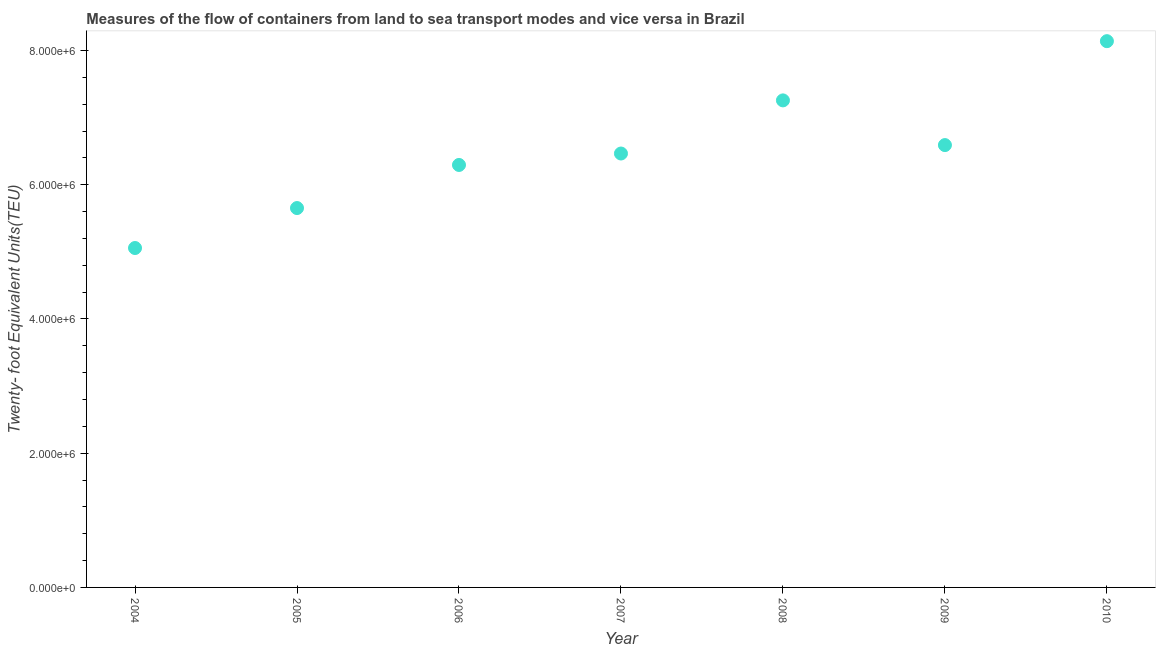What is the container port traffic in 2009?
Your response must be concise. 6.59e+06. Across all years, what is the maximum container port traffic?
Provide a short and direct response. 8.14e+06. Across all years, what is the minimum container port traffic?
Keep it short and to the point. 5.06e+06. What is the sum of the container port traffic?
Make the answer very short. 4.55e+07. What is the difference between the container port traffic in 2005 and 2006?
Keep it short and to the point. -6.42e+05. What is the average container port traffic per year?
Your answer should be very brief. 6.49e+06. What is the median container port traffic?
Give a very brief answer. 6.46e+06. In how many years, is the container port traffic greater than 3600000 TEU?
Your response must be concise. 7. What is the ratio of the container port traffic in 2005 to that in 2009?
Offer a very short reply. 0.86. Is the difference between the container port traffic in 2007 and 2009 greater than the difference between any two years?
Offer a terse response. No. What is the difference between the highest and the second highest container port traffic?
Make the answer very short. 8.82e+05. What is the difference between the highest and the lowest container port traffic?
Your response must be concise. 3.08e+06. In how many years, is the container port traffic greater than the average container port traffic taken over all years?
Your answer should be very brief. 3. Does the container port traffic monotonically increase over the years?
Provide a succinct answer. No. How many dotlines are there?
Keep it short and to the point. 1. What is the difference between two consecutive major ticks on the Y-axis?
Offer a very short reply. 2.00e+06. What is the title of the graph?
Provide a succinct answer. Measures of the flow of containers from land to sea transport modes and vice versa in Brazil. What is the label or title of the Y-axis?
Offer a very short reply. Twenty- foot Equivalent Units(TEU). What is the Twenty- foot Equivalent Units(TEU) in 2004?
Provide a succinct answer. 5.06e+06. What is the Twenty- foot Equivalent Units(TEU) in 2005?
Keep it short and to the point. 5.65e+06. What is the Twenty- foot Equivalent Units(TEU) in 2006?
Ensure brevity in your answer.  6.29e+06. What is the Twenty- foot Equivalent Units(TEU) in 2007?
Your response must be concise. 6.46e+06. What is the Twenty- foot Equivalent Units(TEU) in 2008?
Provide a short and direct response. 7.26e+06. What is the Twenty- foot Equivalent Units(TEU) in 2009?
Your answer should be compact. 6.59e+06. What is the Twenty- foot Equivalent Units(TEU) in 2010?
Provide a short and direct response. 8.14e+06. What is the difference between the Twenty- foot Equivalent Units(TEU) in 2004 and 2005?
Offer a terse response. -5.95e+05. What is the difference between the Twenty- foot Equivalent Units(TEU) in 2004 and 2006?
Your answer should be very brief. -1.24e+06. What is the difference between the Twenty- foot Equivalent Units(TEU) in 2004 and 2007?
Offer a terse response. -1.41e+06. What is the difference between the Twenty- foot Equivalent Units(TEU) in 2004 and 2008?
Keep it short and to the point. -2.20e+06. What is the difference between the Twenty- foot Equivalent Units(TEU) in 2004 and 2009?
Make the answer very short. -1.53e+06. What is the difference between the Twenty- foot Equivalent Units(TEU) in 2004 and 2010?
Make the answer very short. -3.08e+06. What is the difference between the Twenty- foot Equivalent Units(TEU) in 2005 and 2006?
Ensure brevity in your answer.  -6.42e+05. What is the difference between the Twenty- foot Equivalent Units(TEU) in 2005 and 2007?
Your response must be concise. -8.13e+05. What is the difference between the Twenty- foot Equivalent Units(TEU) in 2005 and 2008?
Provide a succinct answer. -1.60e+06. What is the difference between the Twenty- foot Equivalent Units(TEU) in 2005 and 2009?
Your answer should be compact. -9.38e+05. What is the difference between the Twenty- foot Equivalent Units(TEU) in 2005 and 2010?
Your response must be concise. -2.49e+06. What is the difference between the Twenty- foot Equivalent Units(TEU) in 2006 and 2007?
Give a very brief answer. -1.70e+05. What is the difference between the Twenty- foot Equivalent Units(TEU) in 2006 and 2008?
Your answer should be compact. -9.62e+05. What is the difference between the Twenty- foot Equivalent Units(TEU) in 2006 and 2009?
Keep it short and to the point. -2.96e+05. What is the difference between the Twenty- foot Equivalent Units(TEU) in 2006 and 2010?
Offer a terse response. -1.84e+06. What is the difference between the Twenty- foot Equivalent Units(TEU) in 2007 and 2008?
Your response must be concise. -7.92e+05. What is the difference between the Twenty- foot Equivalent Units(TEU) in 2007 and 2009?
Offer a terse response. -1.26e+05. What is the difference between the Twenty- foot Equivalent Units(TEU) in 2007 and 2010?
Offer a very short reply. -1.67e+06. What is the difference between the Twenty- foot Equivalent Units(TEU) in 2008 and 2009?
Your response must be concise. 6.66e+05. What is the difference between the Twenty- foot Equivalent Units(TEU) in 2008 and 2010?
Give a very brief answer. -8.82e+05. What is the difference between the Twenty- foot Equivalent Units(TEU) in 2009 and 2010?
Make the answer very short. -1.55e+06. What is the ratio of the Twenty- foot Equivalent Units(TEU) in 2004 to that in 2005?
Provide a short and direct response. 0.9. What is the ratio of the Twenty- foot Equivalent Units(TEU) in 2004 to that in 2006?
Your response must be concise. 0.8. What is the ratio of the Twenty- foot Equivalent Units(TEU) in 2004 to that in 2007?
Keep it short and to the point. 0.78. What is the ratio of the Twenty- foot Equivalent Units(TEU) in 2004 to that in 2008?
Your answer should be compact. 0.7. What is the ratio of the Twenty- foot Equivalent Units(TEU) in 2004 to that in 2009?
Ensure brevity in your answer.  0.77. What is the ratio of the Twenty- foot Equivalent Units(TEU) in 2004 to that in 2010?
Keep it short and to the point. 0.62. What is the ratio of the Twenty- foot Equivalent Units(TEU) in 2005 to that in 2006?
Ensure brevity in your answer.  0.9. What is the ratio of the Twenty- foot Equivalent Units(TEU) in 2005 to that in 2007?
Keep it short and to the point. 0.87. What is the ratio of the Twenty- foot Equivalent Units(TEU) in 2005 to that in 2008?
Make the answer very short. 0.78. What is the ratio of the Twenty- foot Equivalent Units(TEU) in 2005 to that in 2009?
Your answer should be compact. 0.86. What is the ratio of the Twenty- foot Equivalent Units(TEU) in 2005 to that in 2010?
Make the answer very short. 0.69. What is the ratio of the Twenty- foot Equivalent Units(TEU) in 2006 to that in 2008?
Offer a terse response. 0.87. What is the ratio of the Twenty- foot Equivalent Units(TEU) in 2006 to that in 2009?
Provide a short and direct response. 0.95. What is the ratio of the Twenty- foot Equivalent Units(TEU) in 2006 to that in 2010?
Provide a succinct answer. 0.77. What is the ratio of the Twenty- foot Equivalent Units(TEU) in 2007 to that in 2008?
Offer a very short reply. 0.89. What is the ratio of the Twenty- foot Equivalent Units(TEU) in 2007 to that in 2010?
Provide a succinct answer. 0.79. What is the ratio of the Twenty- foot Equivalent Units(TEU) in 2008 to that in 2009?
Your answer should be compact. 1.1. What is the ratio of the Twenty- foot Equivalent Units(TEU) in 2008 to that in 2010?
Your answer should be compact. 0.89. What is the ratio of the Twenty- foot Equivalent Units(TEU) in 2009 to that in 2010?
Provide a short and direct response. 0.81. 